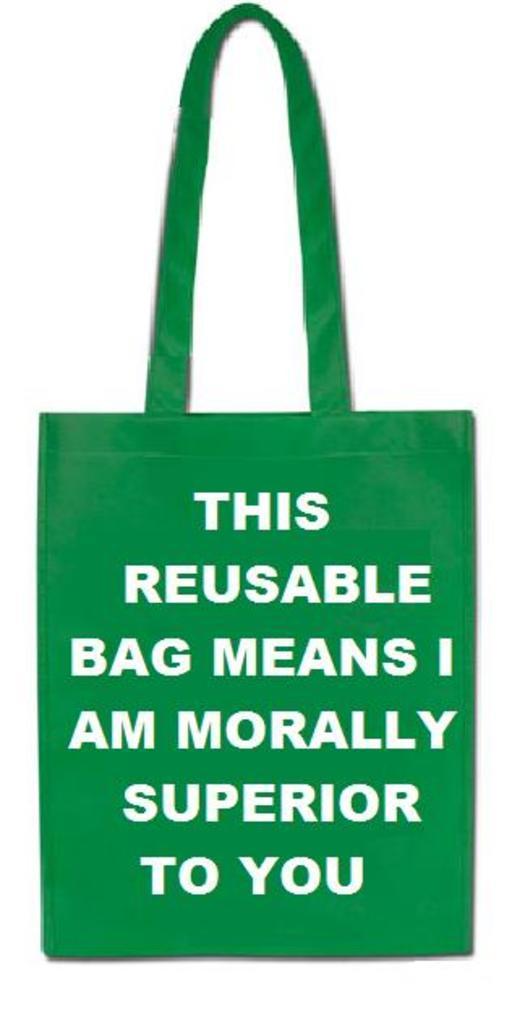In one or two sentences, can you explain what this image depicts? This picture contains bag which is green in color. On bag, it is written as "this reusable bag means I am morally superior to you". 